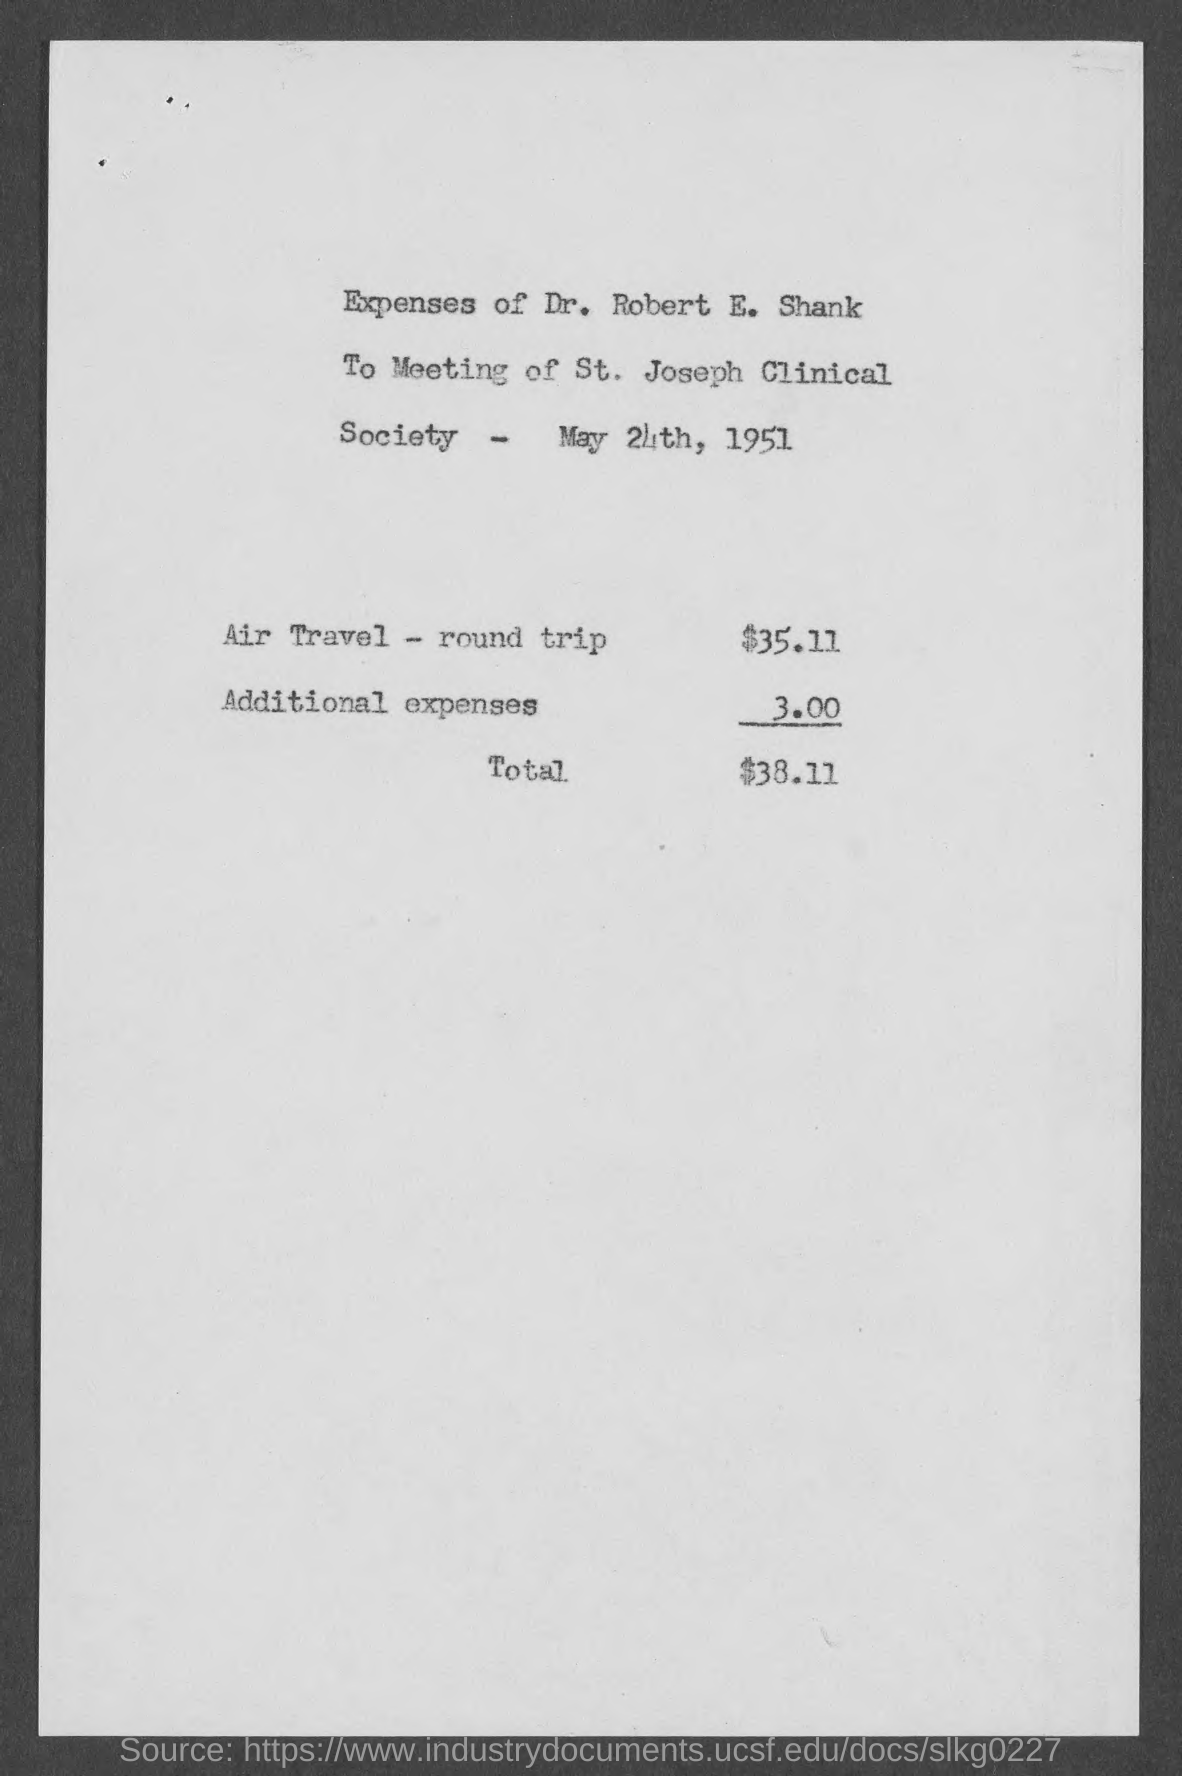Identify some key points in this picture. The additional expenses amount to $3.00. The expense for round-trip air travel was $35.11. The total amount is $38.11. The expenses of Dr. Robert E. Shank are specified in the page. 